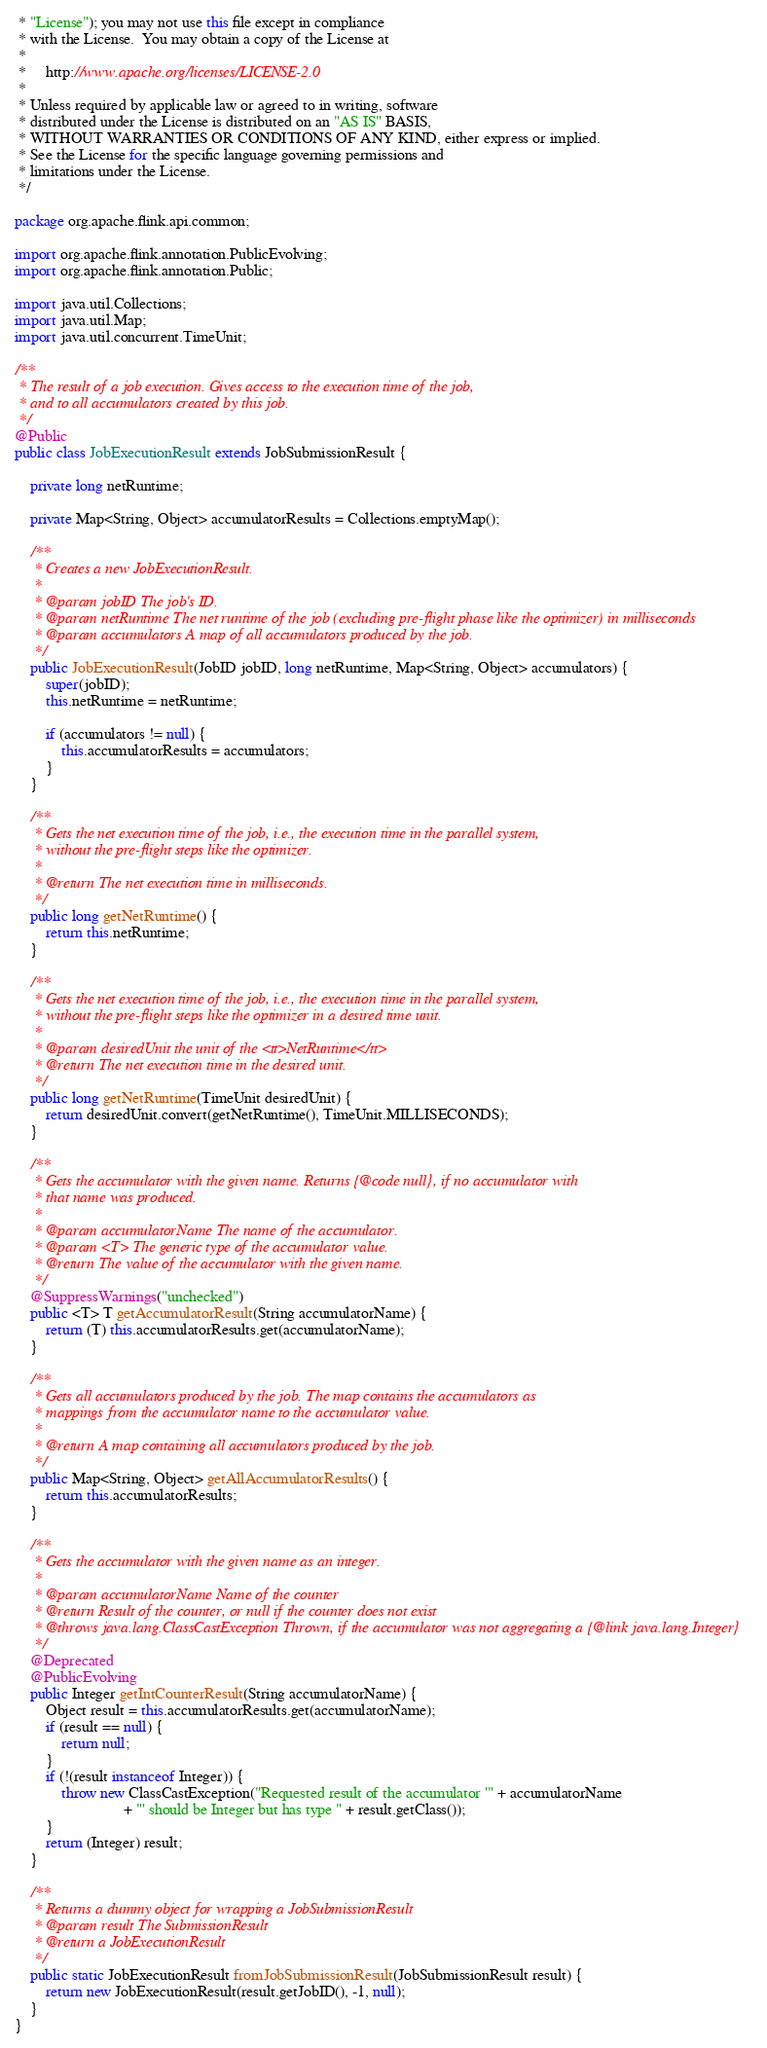Convert code to text. <code><loc_0><loc_0><loc_500><loc_500><_Java_> * "License"); you may not use this file except in compliance
 * with the License.  You may obtain a copy of the License at
 *
 *     http://www.apache.org/licenses/LICENSE-2.0
 *
 * Unless required by applicable law or agreed to in writing, software
 * distributed under the License is distributed on an "AS IS" BASIS,
 * WITHOUT WARRANTIES OR CONDITIONS OF ANY KIND, either express or implied.
 * See the License for the specific language governing permissions and
 * limitations under the License.
 */

package org.apache.flink.api.common;

import org.apache.flink.annotation.PublicEvolving;
import org.apache.flink.annotation.Public;

import java.util.Collections;
import java.util.Map;
import java.util.concurrent.TimeUnit;

/**
 * The result of a job execution. Gives access to the execution time of the job,
 * and to all accumulators created by this job.
 */
@Public
public class JobExecutionResult extends JobSubmissionResult {

	private long netRuntime;

	private Map<String, Object> accumulatorResults = Collections.emptyMap();

	/**
	 * Creates a new JobExecutionResult.
	 *
	 * @param jobID The job's ID.
	 * @param netRuntime The net runtime of the job (excluding pre-flight phase like the optimizer) in milliseconds
	 * @param accumulators A map of all accumulators produced by the job.
	 */
	public JobExecutionResult(JobID jobID, long netRuntime, Map<String, Object> accumulators) {
		super(jobID);
		this.netRuntime = netRuntime;

		if (accumulators != null) {
			this.accumulatorResults = accumulators;
		}
	}

	/**
	 * Gets the net execution time of the job, i.e., the execution time in the parallel system,
	 * without the pre-flight steps like the optimizer.
	 *
	 * @return The net execution time in milliseconds.
	 */
	public long getNetRuntime() {
		return this.netRuntime;
	}

    /**
	 * Gets the net execution time of the job, i.e., the execution time in the parallel system,
	 * without the pre-flight steps like the optimizer in a desired time unit.
	 *
	 * @param desiredUnit the unit of the <tt>NetRuntime</tt>
	 * @return The net execution time in the desired unit.
	 */
	public long getNetRuntime(TimeUnit desiredUnit) {
		return desiredUnit.convert(getNetRuntime(), TimeUnit.MILLISECONDS);
	}

	/**
	 * Gets the accumulator with the given name. Returns {@code null}, if no accumulator with
	 * that name was produced.
	 *
	 * @param accumulatorName The name of the accumulator.
	 * @param <T> The generic type of the accumulator value.
	 * @return The value of the accumulator with the given name.
	 */
	@SuppressWarnings("unchecked")
	public <T> T getAccumulatorResult(String accumulatorName) {
		return (T) this.accumulatorResults.get(accumulatorName);
	}

	/**
	 * Gets all accumulators produced by the job. The map contains the accumulators as
	 * mappings from the accumulator name to the accumulator value.
	 *
	 * @return A map containing all accumulators produced by the job.
	 */
	public Map<String, Object> getAllAccumulatorResults() {
		return this.accumulatorResults;
	}
	
	/**
	 * Gets the accumulator with the given name as an integer.
	 *
	 * @param accumulatorName Name of the counter
	 * @return Result of the counter, or null if the counter does not exist
	 * @throws java.lang.ClassCastException Thrown, if the accumulator was not aggregating a {@link java.lang.Integer}
	 */
	@Deprecated
	@PublicEvolving
	public Integer getIntCounterResult(String accumulatorName) {
		Object result = this.accumulatorResults.get(accumulatorName);
		if (result == null) {
			return null;
		}
		if (!(result instanceof Integer)) {
			throw new ClassCastException("Requested result of the accumulator '" + accumulatorName
							+ "' should be Integer but has type " + result.getClass());
		}
		return (Integer) result;
	}

	/**
	 * Returns a dummy object for wrapping a JobSubmissionResult
	 * @param result The SubmissionResult
	 * @return a JobExecutionResult
	 */
	public static JobExecutionResult fromJobSubmissionResult(JobSubmissionResult result) {
		return new JobExecutionResult(result.getJobID(), -1, null);
	}
}
</code> 